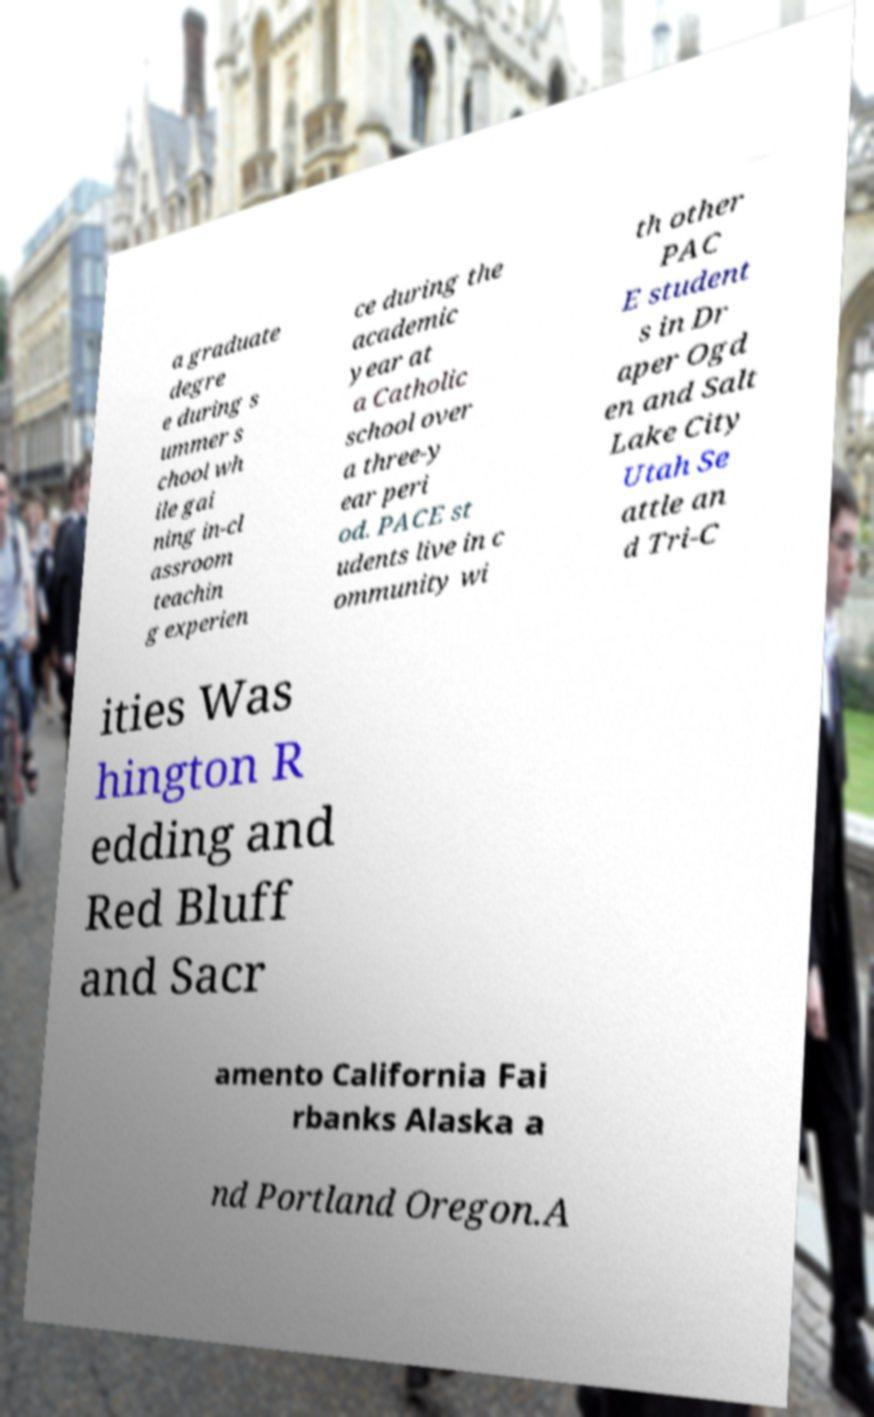Can you read and provide the text displayed in the image?This photo seems to have some interesting text. Can you extract and type it out for me? a graduate degre e during s ummer s chool wh ile gai ning in-cl assroom teachin g experien ce during the academic year at a Catholic school over a three-y ear peri od. PACE st udents live in c ommunity wi th other PAC E student s in Dr aper Ogd en and Salt Lake City Utah Se attle an d Tri-C ities Was hington R edding and Red Bluff and Sacr amento California Fai rbanks Alaska a nd Portland Oregon.A 